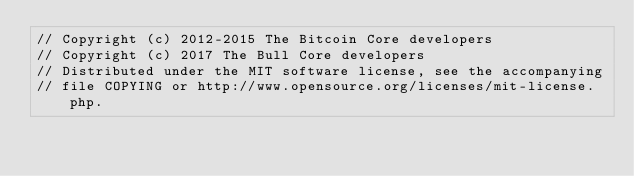Convert code to text. <code><loc_0><loc_0><loc_500><loc_500><_C++_>// Copyright (c) 2012-2015 The Bitcoin Core developers
// Copyright (c) 2017 The Bull Core developers
// Distributed under the MIT software license, see the accompanying
// file COPYING or http://www.opensource.org/licenses/mit-license.php.
</code> 